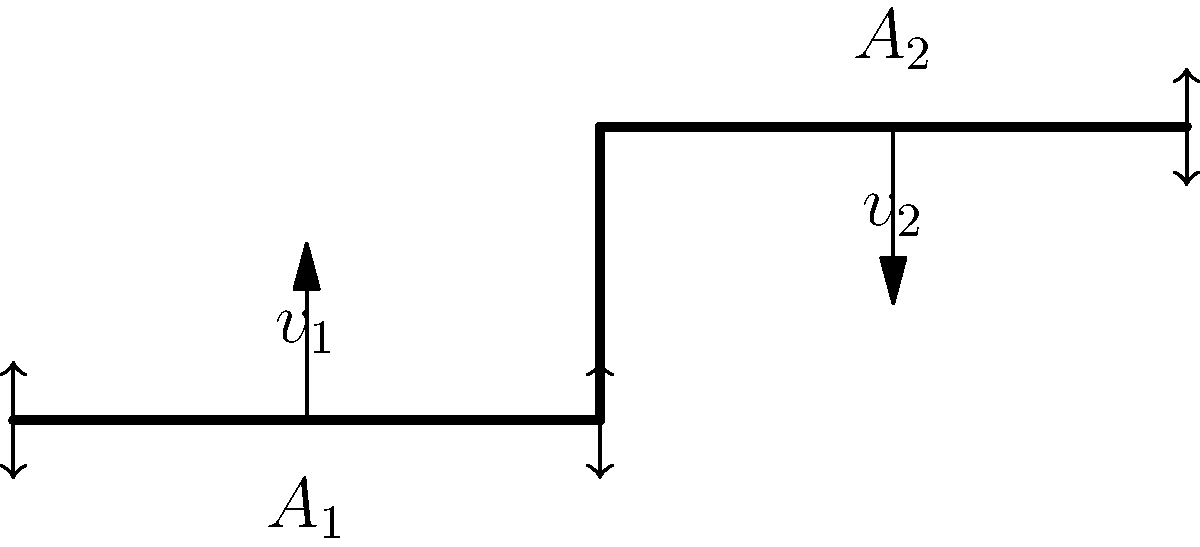In your small business workshop, you're designing a water delivery system. The pipe has two sections with cross-sectional areas $A_1$ and $A_2$, where $A_2 = 0.5A_1$. If the water velocity at the inlet ($v_1$) is 2 m/s, what is the velocity ($v_2$) at the outlet? Assume the flow is incompressible and steady. To solve this problem, we'll use the continuity equation for incompressible flow. The steps are as follows:

1) The continuity equation states that the mass flow rate is constant throughout the pipe:

   $\rho_1 A_1 v_1 = \rho_2 A_2 v_2$

2) For incompressible flow, the density ($\rho$) is constant, so we can simplify:

   $A_1 v_1 = A_2 v_2$

3) We're given that $A_2 = 0.5A_1$ and $v_1 = 2$ m/s. Let's substitute these:

   $A_1 \cdot 2 = 0.5A_1 \cdot v_2$

4) Simplify:

   $2 = 0.5v_2$

5) Solve for $v_2$:

   $v_2 = \frac{2}{0.5} = 4$ m/s

Therefore, the velocity at the outlet ($v_2$) is 4 m/s.
Answer: 4 m/s 